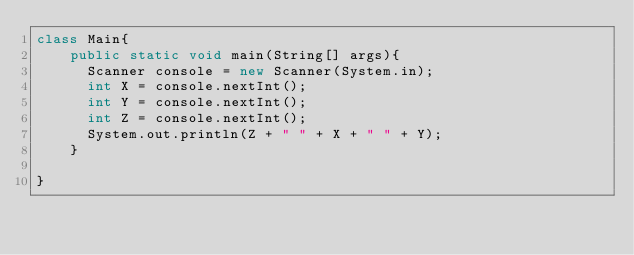Convert code to text. <code><loc_0><loc_0><loc_500><loc_500><_Java_>class Main{
	public static void main(String[] args){
      Scanner console = new Scanner(System.in);
      int X = console.nextInt();
      int Y = console.nextInt();
      int Z = console.nextInt();
      System.out.println(Z + " " + X + " " + Y);
	}
	
}</code> 